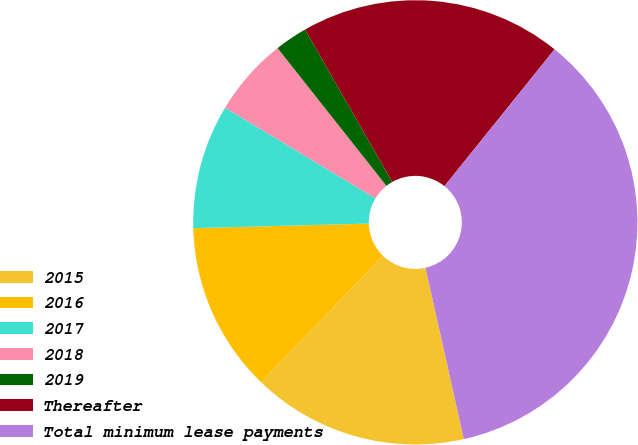<chart> <loc_0><loc_0><loc_500><loc_500><pie_chart><fcel>2015<fcel>2016<fcel>2017<fcel>2018<fcel>2019<fcel>Thereafter<fcel>Total minimum lease payments<nl><fcel>15.71%<fcel>12.38%<fcel>9.05%<fcel>5.72%<fcel>2.38%<fcel>19.05%<fcel>35.71%<nl></chart> 